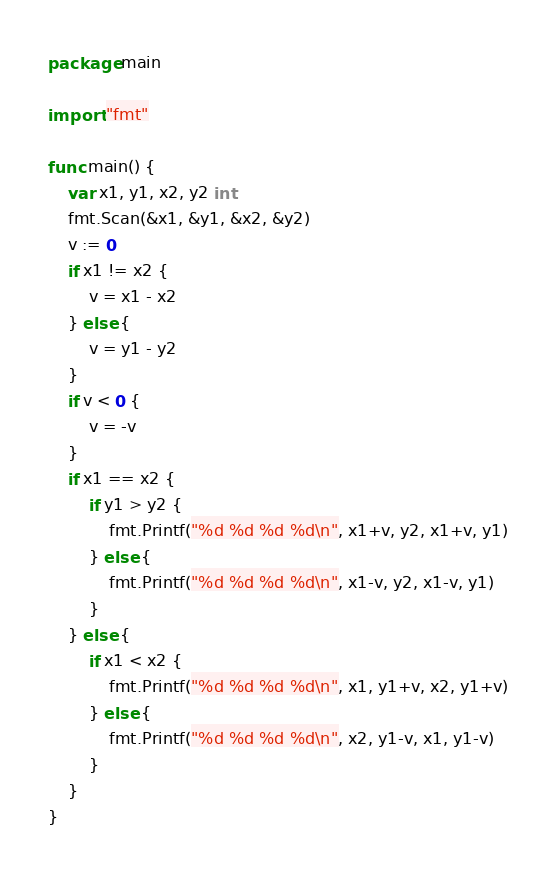Convert code to text. <code><loc_0><loc_0><loc_500><loc_500><_Go_>package main

import "fmt"

func main() {
	var x1, y1, x2, y2 int
	fmt.Scan(&x1, &y1, &x2, &y2)
	v := 0
	if x1 != x2 {
		v = x1 - x2
	} else {
		v = y1 - y2
	}
	if v < 0 {
		v = -v
	}
	if x1 == x2 {
		if y1 > y2 {
			fmt.Printf("%d %d %d %d\n", x1+v, y2, x1+v, y1)
		} else {
			fmt.Printf("%d %d %d %d\n", x1-v, y2, x1-v, y1)
		}
	} else {
		if x1 < x2 {
			fmt.Printf("%d %d %d %d\n", x1, y1+v, x2, y1+v)
		} else {
			fmt.Printf("%d %d %d %d\n", x2, y1-v, x1, y1-v)
		}
	}
}
</code> 